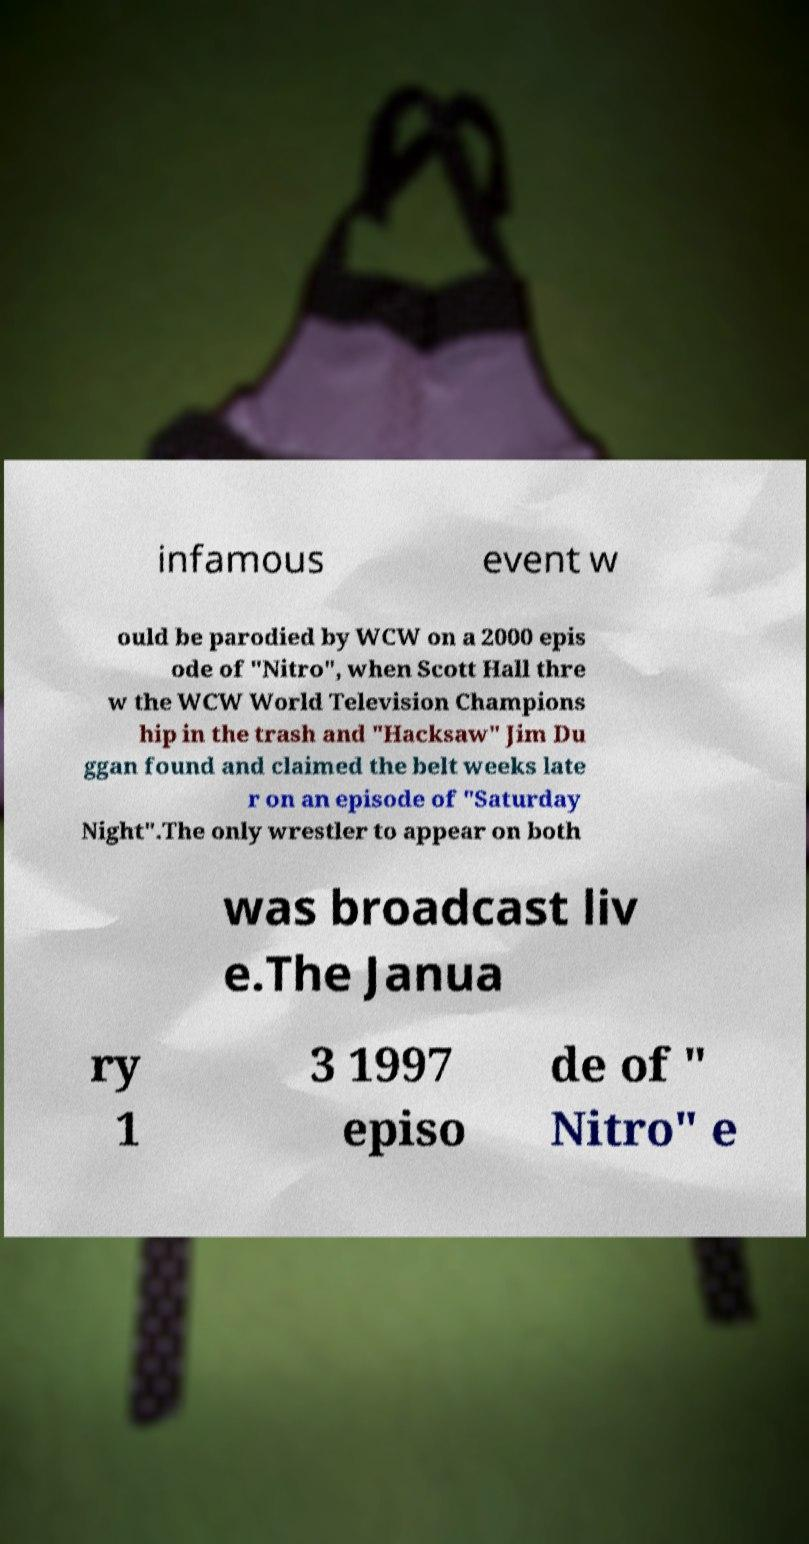What messages or text are displayed in this image? I need them in a readable, typed format. infamous event w ould be parodied by WCW on a 2000 epis ode of "Nitro", when Scott Hall thre w the WCW World Television Champions hip in the trash and "Hacksaw" Jim Du ggan found and claimed the belt weeks late r on an episode of "Saturday Night".The only wrestler to appear on both was broadcast liv e.The Janua ry 1 3 1997 episo de of " Nitro" e 